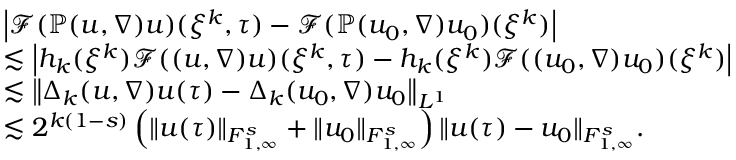<formula> <loc_0><loc_0><loc_500><loc_500>\begin{array} { r l } & { \left | \mathcal { F } ( \mathbb { P } ( u , \nabla ) u ) ( \xi ^ { k } , \tau ) - \mathcal { F } ( \mathbb { P } ( u _ { 0 } , \nabla ) u _ { 0 } ) ( \xi ^ { k } ) \right | } \\ & { \lesssim \left | h _ { k } ( \xi ^ { k } ) \mathcal { F } ( ( u , \nabla ) u ) ( \xi ^ { k } , \tau ) - h _ { k } ( \xi ^ { k } ) \mathcal { F } ( ( u _ { 0 } , \nabla ) u _ { 0 } ) ( \xi ^ { k } ) \right | } \\ & { \lesssim \left \| \Delta _ { k } ( u , \nabla ) u ( \tau ) - \Delta _ { k } ( u _ { 0 } , \nabla ) u _ { 0 } \right \| _ { L ^ { 1 } } } \\ & { \lesssim 2 ^ { k ( 1 - s ) } \left ( \| u ( \tau ) \| _ { { F } _ { 1 , \infty } ^ { s } } + \| u _ { 0 } \| _ { { F } _ { 1 , \infty } ^ { s } } \right ) \| u ( \tau ) - u _ { 0 } \| _ { { F } _ { 1 , \infty } ^ { s } } . } \end{array}</formula> 